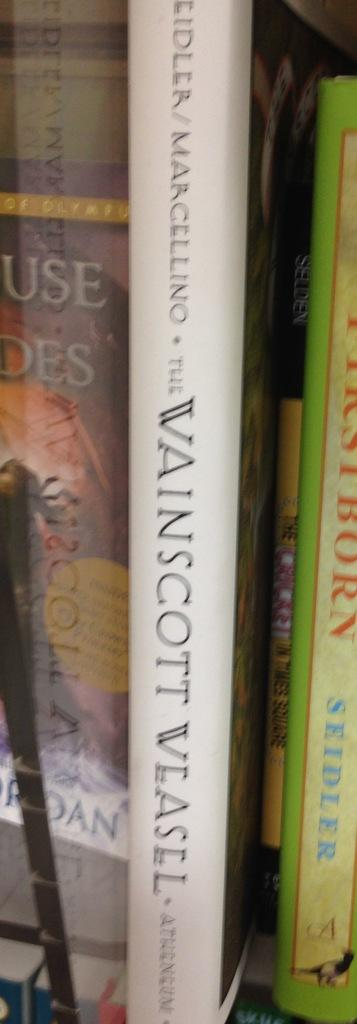Provide a one-sentence caption for the provided image. The book Vainscott Vlasel sits on a bookself. 